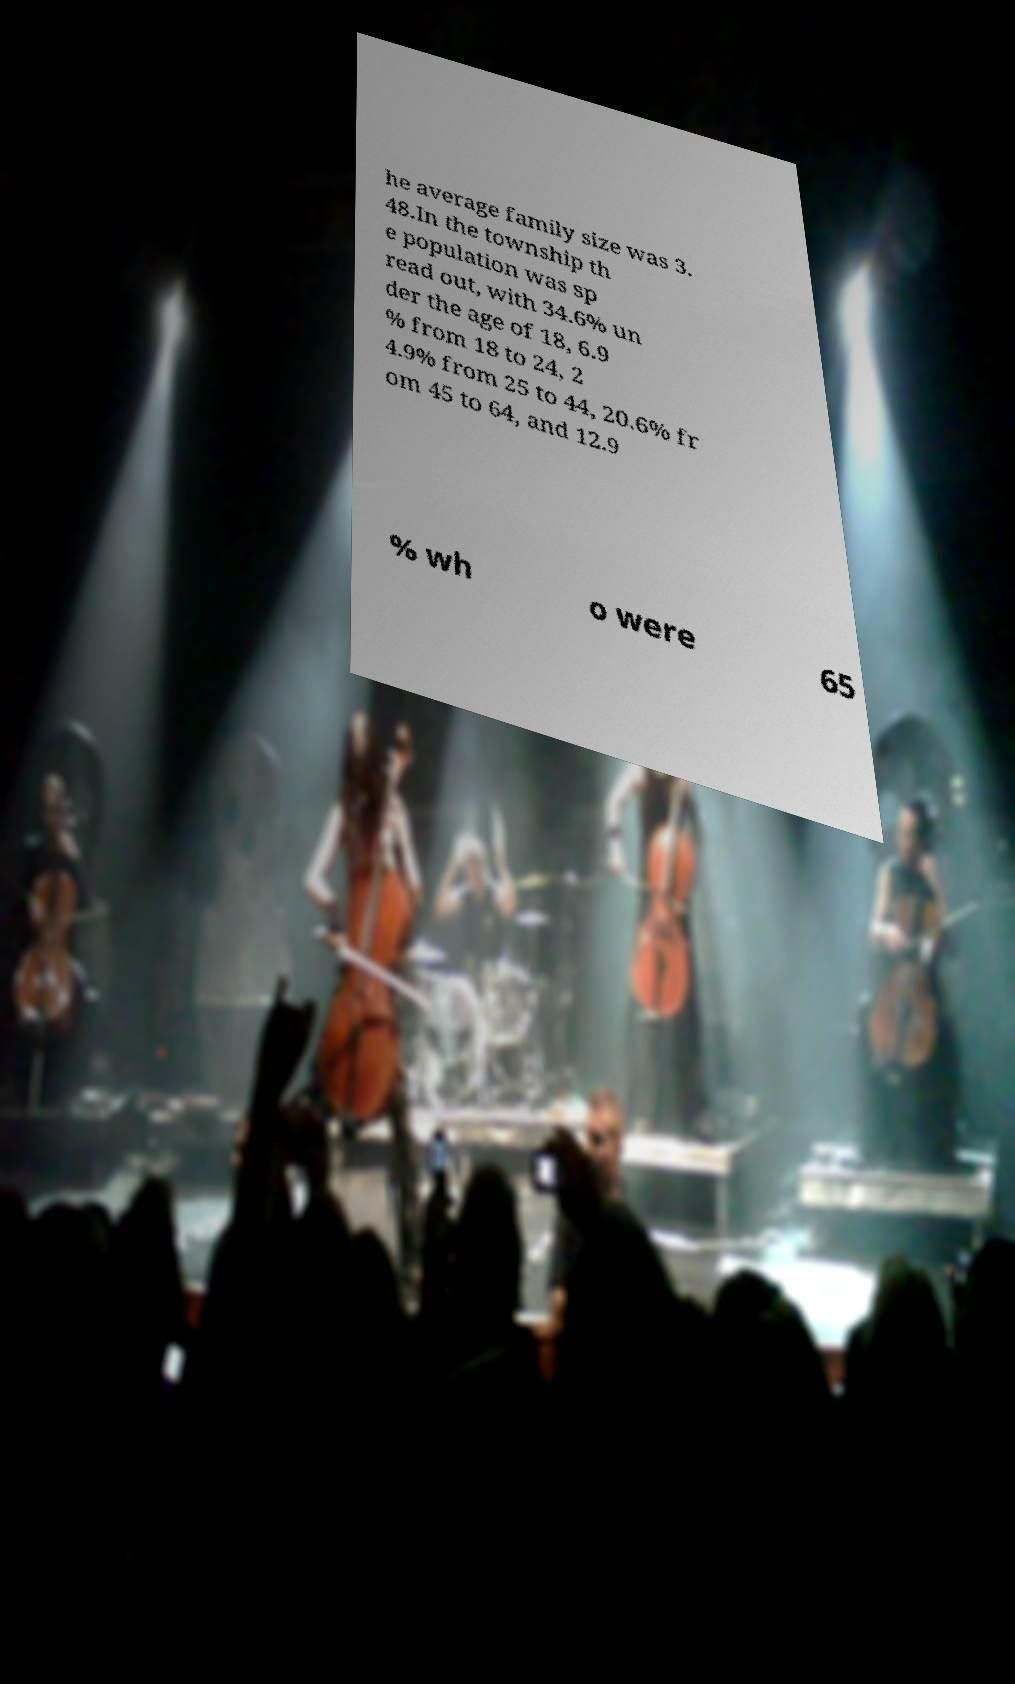Could you extract and type out the text from this image? he average family size was 3. 48.In the township th e population was sp read out, with 34.6% un der the age of 18, 6.9 % from 18 to 24, 2 4.9% from 25 to 44, 20.6% fr om 45 to 64, and 12.9 % wh o were 65 